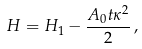Convert formula to latex. <formula><loc_0><loc_0><loc_500><loc_500>H = H _ { 1 } - \frac { A _ { 0 } t \kappa ^ { 2 } } { 2 } \, ,</formula> 